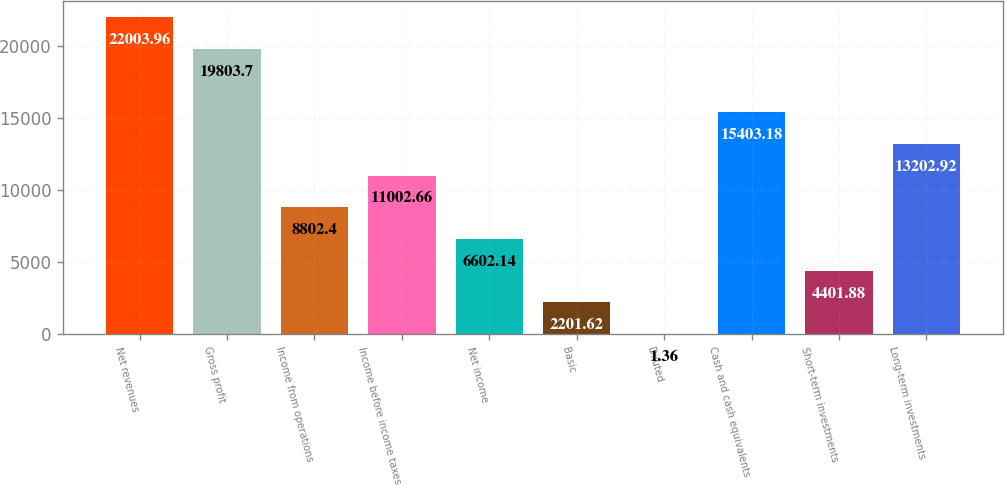Convert chart. <chart><loc_0><loc_0><loc_500><loc_500><bar_chart><fcel>Net revenues<fcel>Gross profit<fcel>Income from operations<fcel>Income before income taxes<fcel>Net income<fcel>Basic<fcel>Diluted<fcel>Cash and cash equivalents<fcel>Short-term investments<fcel>Long-term investments<nl><fcel>22004<fcel>19803.7<fcel>8802.4<fcel>11002.7<fcel>6602.14<fcel>2201.62<fcel>1.36<fcel>15403.2<fcel>4401.88<fcel>13202.9<nl></chart> 